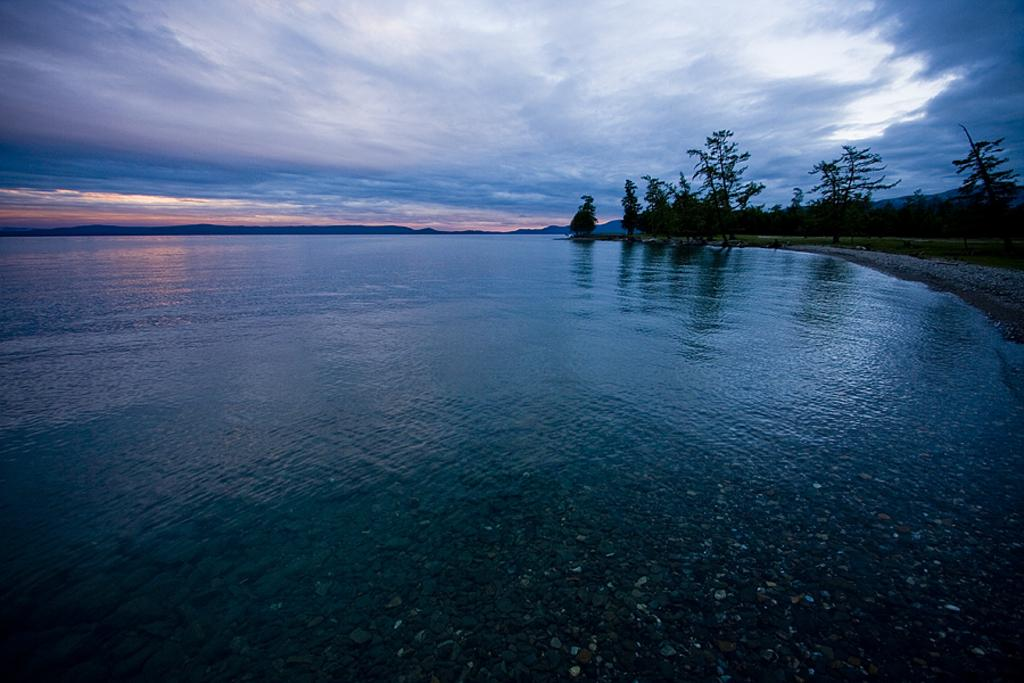What is located in the foreground and towards the left side of the image? There is a water body in the foreground and towards the left side of the image. What type of vegetation can be seen on the right side of the image? There are trees on the right side of the image. What type of terrain is visible in the image? There is land visible in the image. What geographical features can be seen in the background of the image? There are hills in the background of the image. What is visible at the top of the image? The sky is visible at the top of the image. Can you tell me how many ploughs are visible in the image? There are no ploughs present in the image. On which side of the water body are the trees located? The trees are located on the right side of the image, not the side of the water body. 